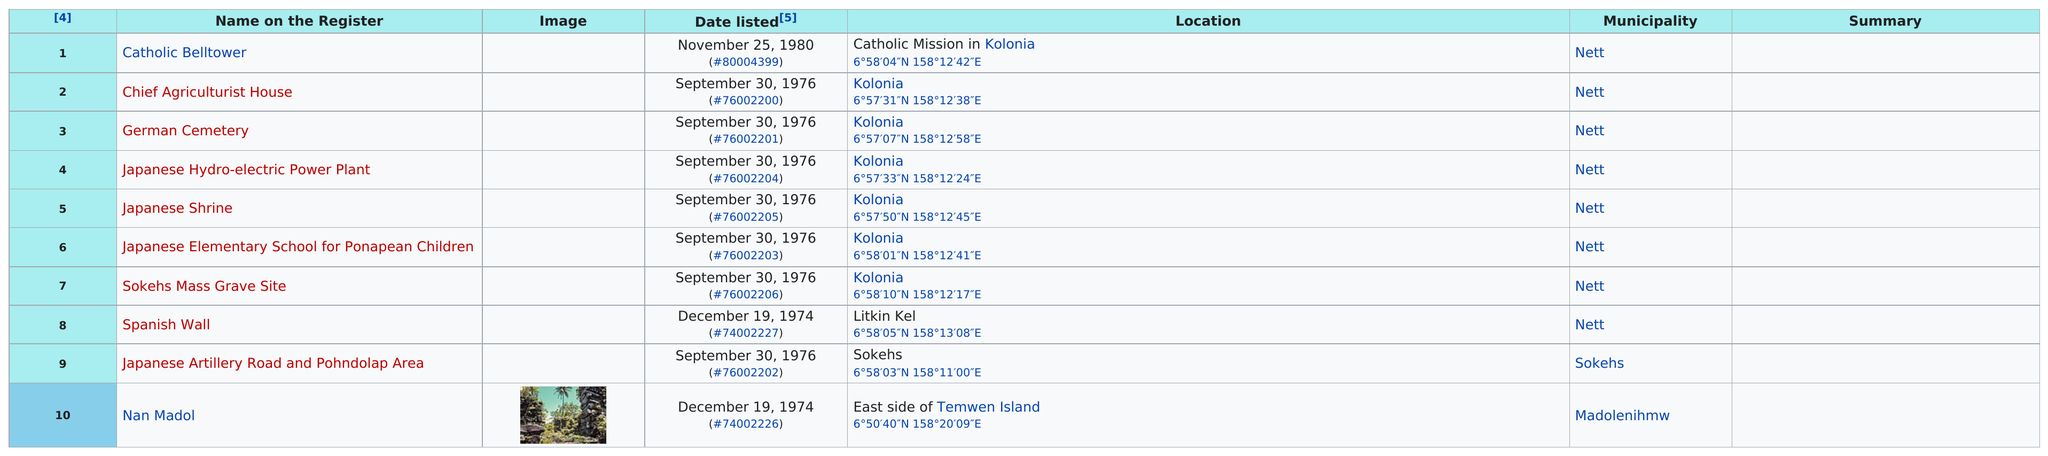Mention a couple of crucial points in this snapshot. The earliest listing to the latest listing is spanned for a total of 6 years. The municipality with the highest number of registered items is Nett.lar. There are two cemeteries listed on the register. 